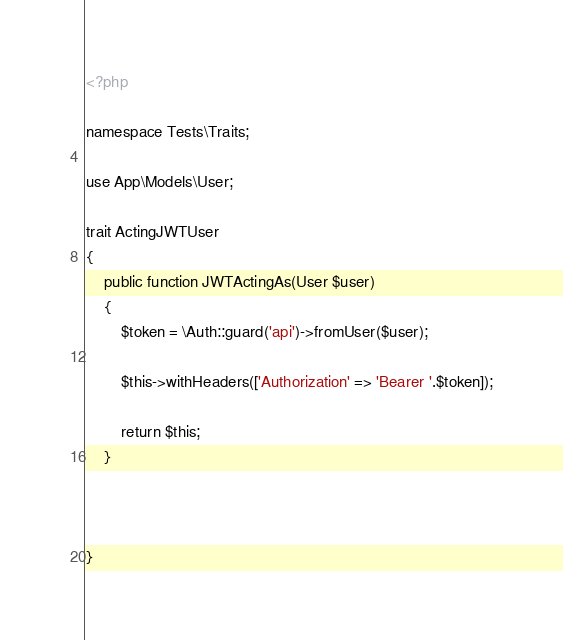Convert code to text. <code><loc_0><loc_0><loc_500><loc_500><_PHP_><?php

namespace Tests\Traits;

use App\Models\User;

trait ActingJWTUser
{
    public function JWTActingAs(User $user)
    {
        $token = \Auth::guard('api')->fromUser($user);

        $this->withHeaders(['Authorization' => 'Bearer '.$token]);

        return $this;
    }



}</code> 